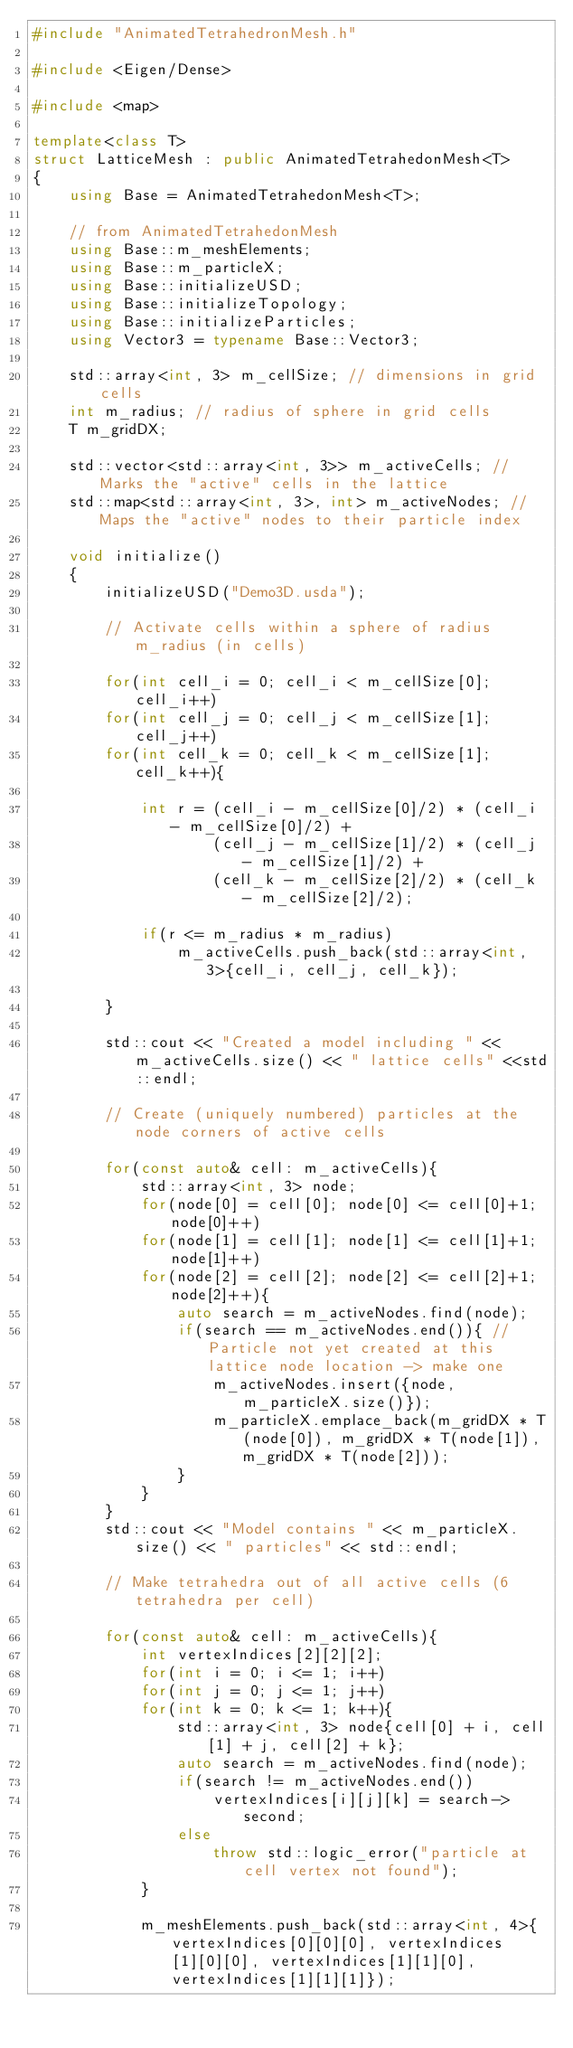<code> <loc_0><loc_0><loc_500><loc_500><_C++_>#include "AnimatedTetrahedronMesh.h"

#include <Eigen/Dense>

#include <map>

template<class T>
struct LatticeMesh : public AnimatedTetrahedonMesh<T>
{
    using Base = AnimatedTetrahedonMesh<T>;

    // from AnimatedTetrahedonMesh
    using Base::m_meshElements;
    using Base::m_particleX;
    using Base::initializeUSD;
    using Base::initializeTopology;
    using Base::initializeParticles;
    using Vector3 = typename Base::Vector3;

    std::array<int, 3> m_cellSize; // dimensions in grid cells
    int m_radius; // radius of sphere in grid cells
    T m_gridDX;

    std::vector<std::array<int, 3>> m_activeCells; // Marks the "active" cells in the lattice
    std::map<std::array<int, 3>, int> m_activeNodes; // Maps the "active" nodes to their particle index

    void initialize()
    {
        initializeUSD("Demo3D.usda");

        // Activate cells within a sphere of radius m_radius (in cells)

        for(int cell_i = 0; cell_i < m_cellSize[0]; cell_i++)
        for(int cell_j = 0; cell_j < m_cellSize[1]; cell_j++)
        for(int cell_k = 0; cell_k < m_cellSize[1]; cell_k++){

            int r = (cell_i - m_cellSize[0]/2) * (cell_i - m_cellSize[0]/2) +
                    (cell_j - m_cellSize[1]/2) * (cell_j - m_cellSize[1]/2) +
                    (cell_k - m_cellSize[2]/2) * (cell_k - m_cellSize[2]/2);

            if(r <= m_radius * m_radius)
                m_activeCells.push_back(std::array<int, 3>{cell_i, cell_j, cell_k});

        }

        std::cout << "Created a model including " << m_activeCells.size() << " lattice cells" <<std::endl;

        // Create (uniquely numbered) particles at the node corners of active cells

        for(const auto& cell: m_activeCells){
            std::array<int, 3> node;
            for(node[0] = cell[0]; node[0] <= cell[0]+1; node[0]++)
            for(node[1] = cell[1]; node[1] <= cell[1]+1; node[1]++)
            for(node[2] = cell[2]; node[2] <= cell[2]+1; node[2]++){
                auto search = m_activeNodes.find(node);
                if(search == m_activeNodes.end()){ // Particle not yet created at this lattice node location -> make one
                    m_activeNodes.insert({node, m_particleX.size()});
                    m_particleX.emplace_back(m_gridDX * T(node[0]), m_gridDX * T(node[1]), m_gridDX * T(node[2]));
                }
            }
        }
        std::cout << "Model contains " << m_particleX.size() << " particles" << std::endl;

        // Make tetrahedra out of all active cells (6 tetrahedra per cell)

        for(const auto& cell: m_activeCells){
            int vertexIndices[2][2][2];
            for(int i = 0; i <= 1; i++)
            for(int j = 0; j <= 1; j++)
            for(int k = 0; k <= 1; k++){
                std::array<int, 3> node{cell[0] + i, cell[1] + j, cell[2] + k};
                auto search = m_activeNodes.find(node);
                if(search != m_activeNodes.end())
                    vertexIndices[i][j][k] = search->second;
                else
                    throw std::logic_error("particle at cell vertex not found");
            }

            m_meshElements.push_back(std::array<int, 4>{ vertexIndices[0][0][0], vertexIndices[1][0][0], vertexIndices[1][1][0], vertexIndices[1][1][1]});</code> 